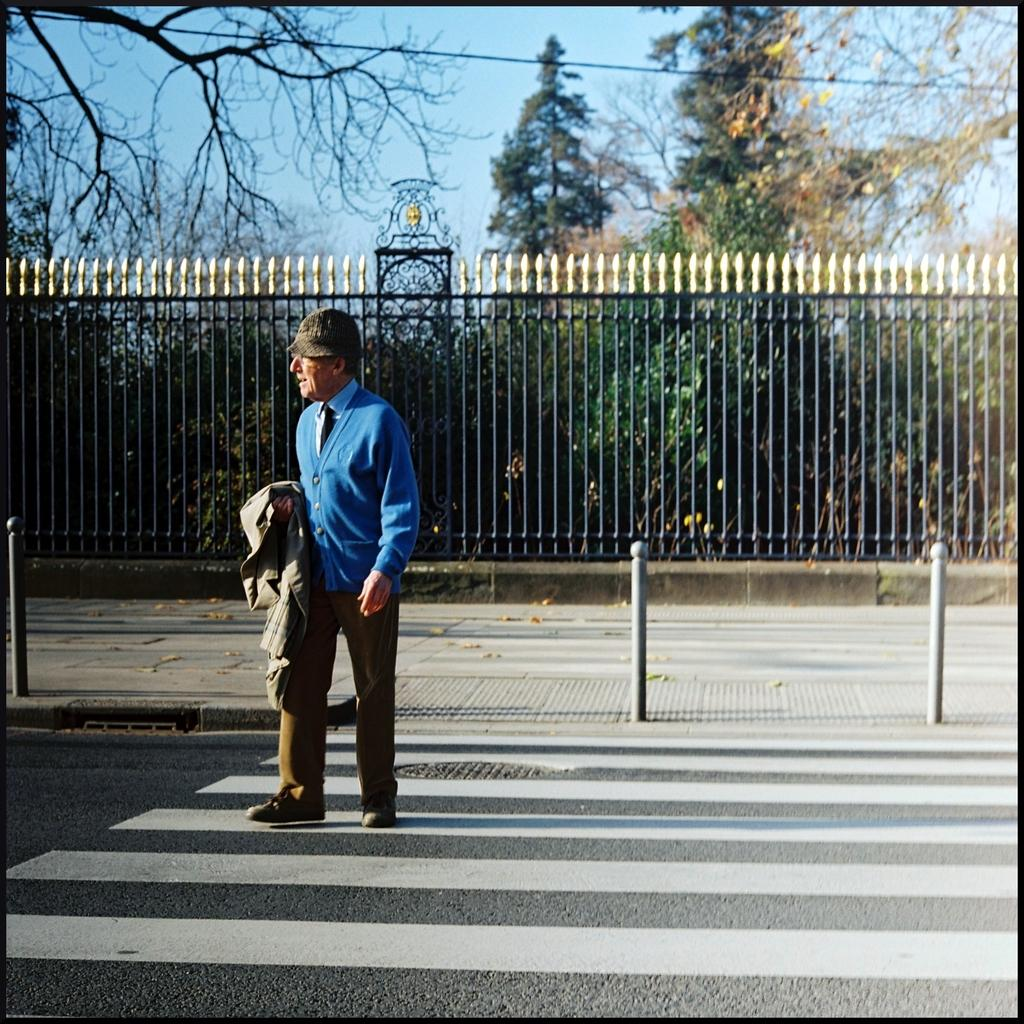What is happening in the image? There is a person on the road in the image. What can be seen in the background of the image? There is a fence, trees, and wires in the background of the image. What is visible at the top of the image? The sky is visible at the top of the image. What is the weather like in the image? The image was taken during a sunny day. How many frogs are sitting on the calculator in the image? There is no calculator or frogs present in the image. What shape is the heart in the image? There is no heart present in the image. 